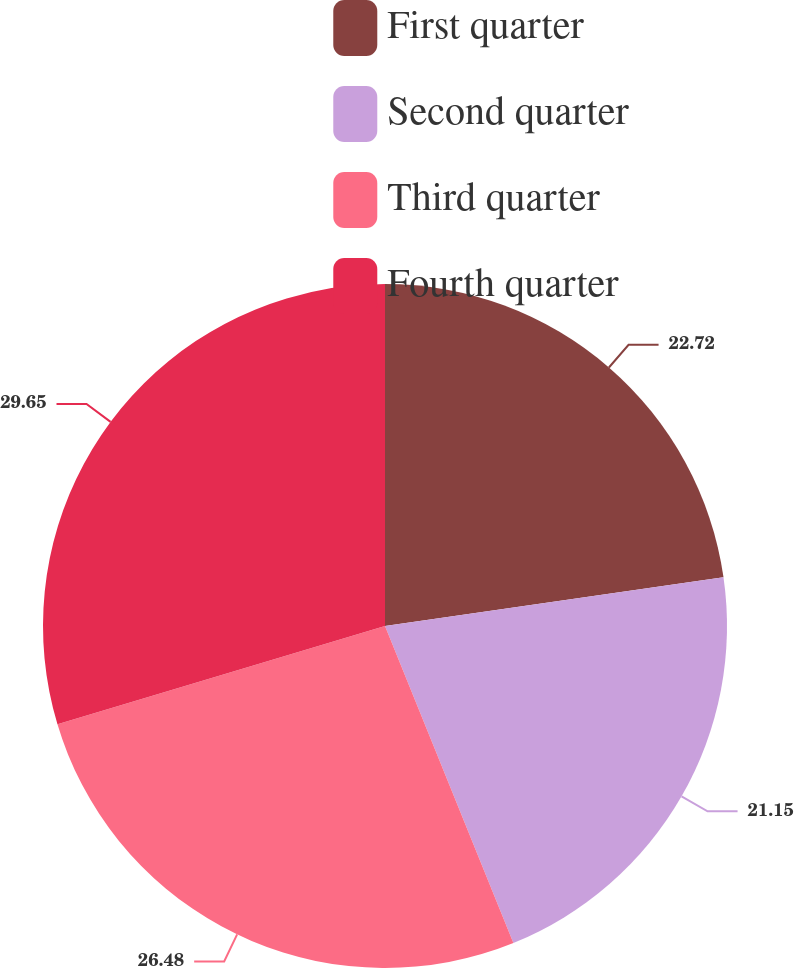<chart> <loc_0><loc_0><loc_500><loc_500><pie_chart><fcel>First quarter<fcel>Second quarter<fcel>Third quarter<fcel>Fourth quarter<nl><fcel>22.72%<fcel>21.15%<fcel>26.48%<fcel>29.64%<nl></chart> 